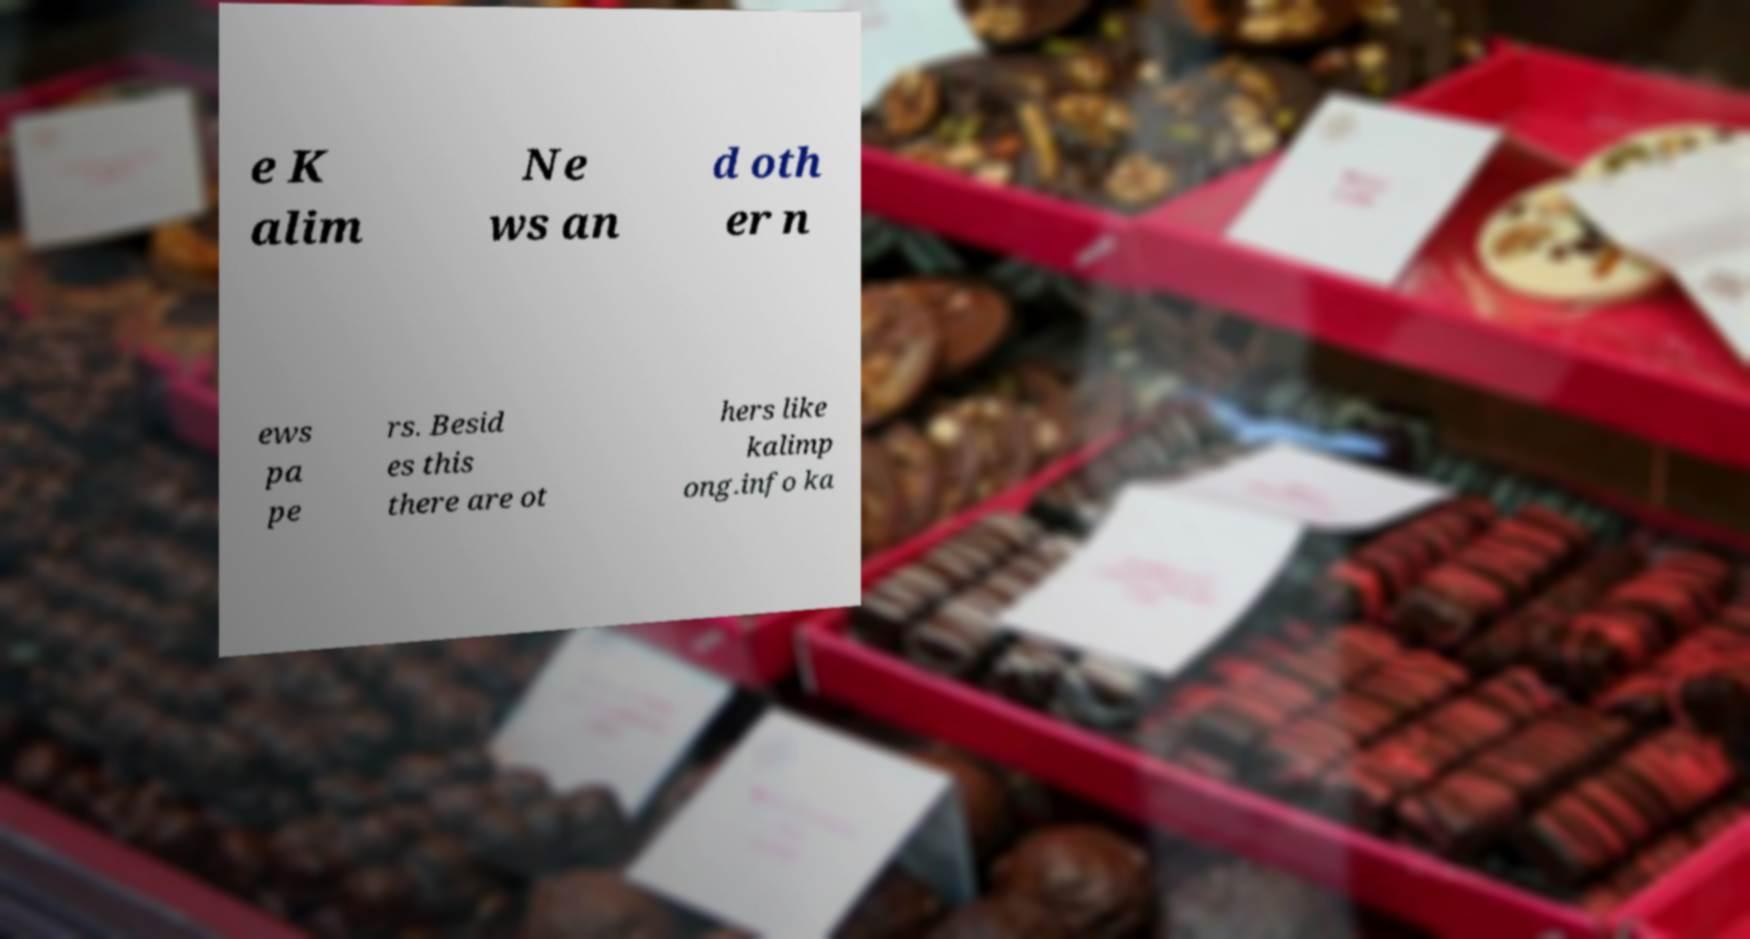Can you read and provide the text displayed in the image?This photo seems to have some interesting text. Can you extract and type it out for me? e K alim Ne ws an d oth er n ews pa pe rs. Besid es this there are ot hers like kalimp ong.info ka 